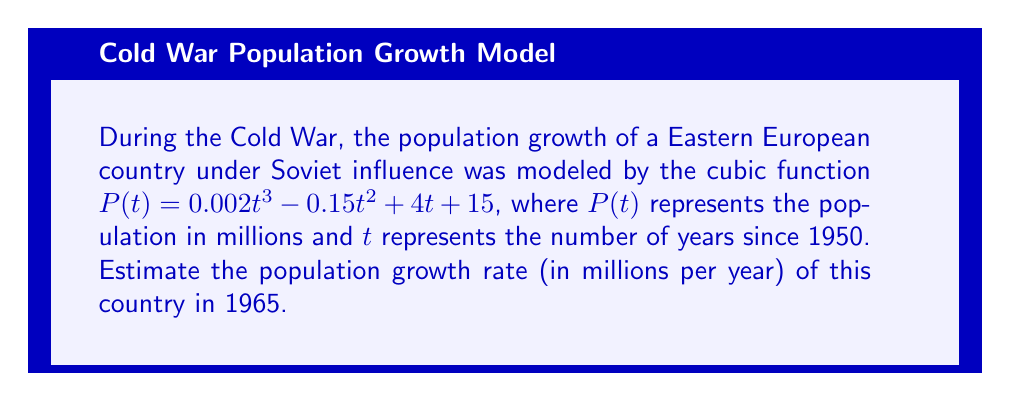Provide a solution to this math problem. To solve this problem, we need to follow these steps:

1) The population growth rate at any given time is represented by the derivative of the population function. So, we need to find $P'(t)$.

2) To find $P'(t)$, we differentiate $P(t)$ with respect to $t$:

   $P'(t) = 0.002 \cdot 3t^2 - 0.15 \cdot 2t + 4$
   $P'(t) = 0.006t^2 - 0.3t + 4$

3) Now, we need to find the value of $t$ that corresponds to the year 1965. Since $t$ represents the number of years since 1950:

   1965 - 1950 = 15 years

4) We can now substitute $t = 15$ into our $P'(t)$ function:

   $P'(15) = 0.006(15)^2 - 0.3(15) + 4$
   $= 0.006(225) - 4.5 + 4$
   $= 1.35 - 4.5 + 4$
   $= 0.85$

Therefore, the estimated population growth rate in 1965 was 0.85 million people per year.
Answer: 0.85 million people per year 